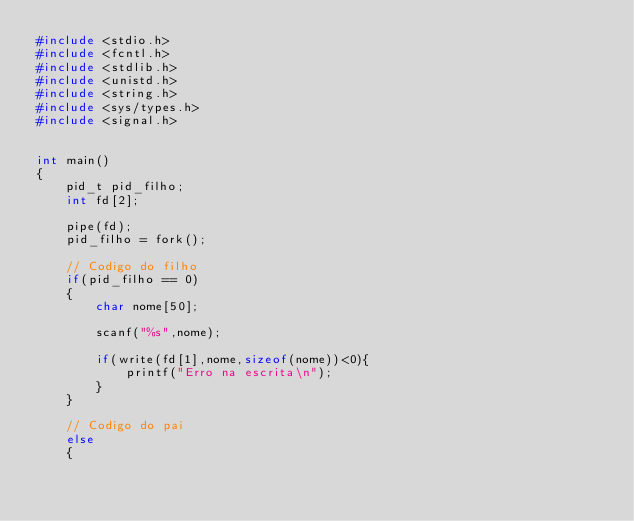<code> <loc_0><loc_0><loc_500><loc_500><_C_>#include <stdio.h>
#include <fcntl.h>
#include <stdlib.h>
#include <unistd.h>
#include <string.h>
#include <sys/types.h>
#include <signal.h>


int main()
{
    pid_t pid_filho;
    int fd[2];
    
    pipe(fd);
    pid_filho = fork();

    // Codigo do filho    
    if(pid_filho == 0)
    {
        char nome[50];

        scanf("%s",nome);

        if(write(fd[1],nome,sizeof(nome))<0){
            printf("Erro na escrita\n");
        }
    }
    
    // Codigo do pai
    else
    {</code> 